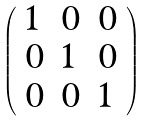<formula> <loc_0><loc_0><loc_500><loc_500>\left ( \begin{array} { l l l } { 1 } & { 0 } & { 0 } \\ { 0 } & { 1 } & { 0 } \\ { 0 } & { 0 } & { 1 } \end{array} \right )</formula> 